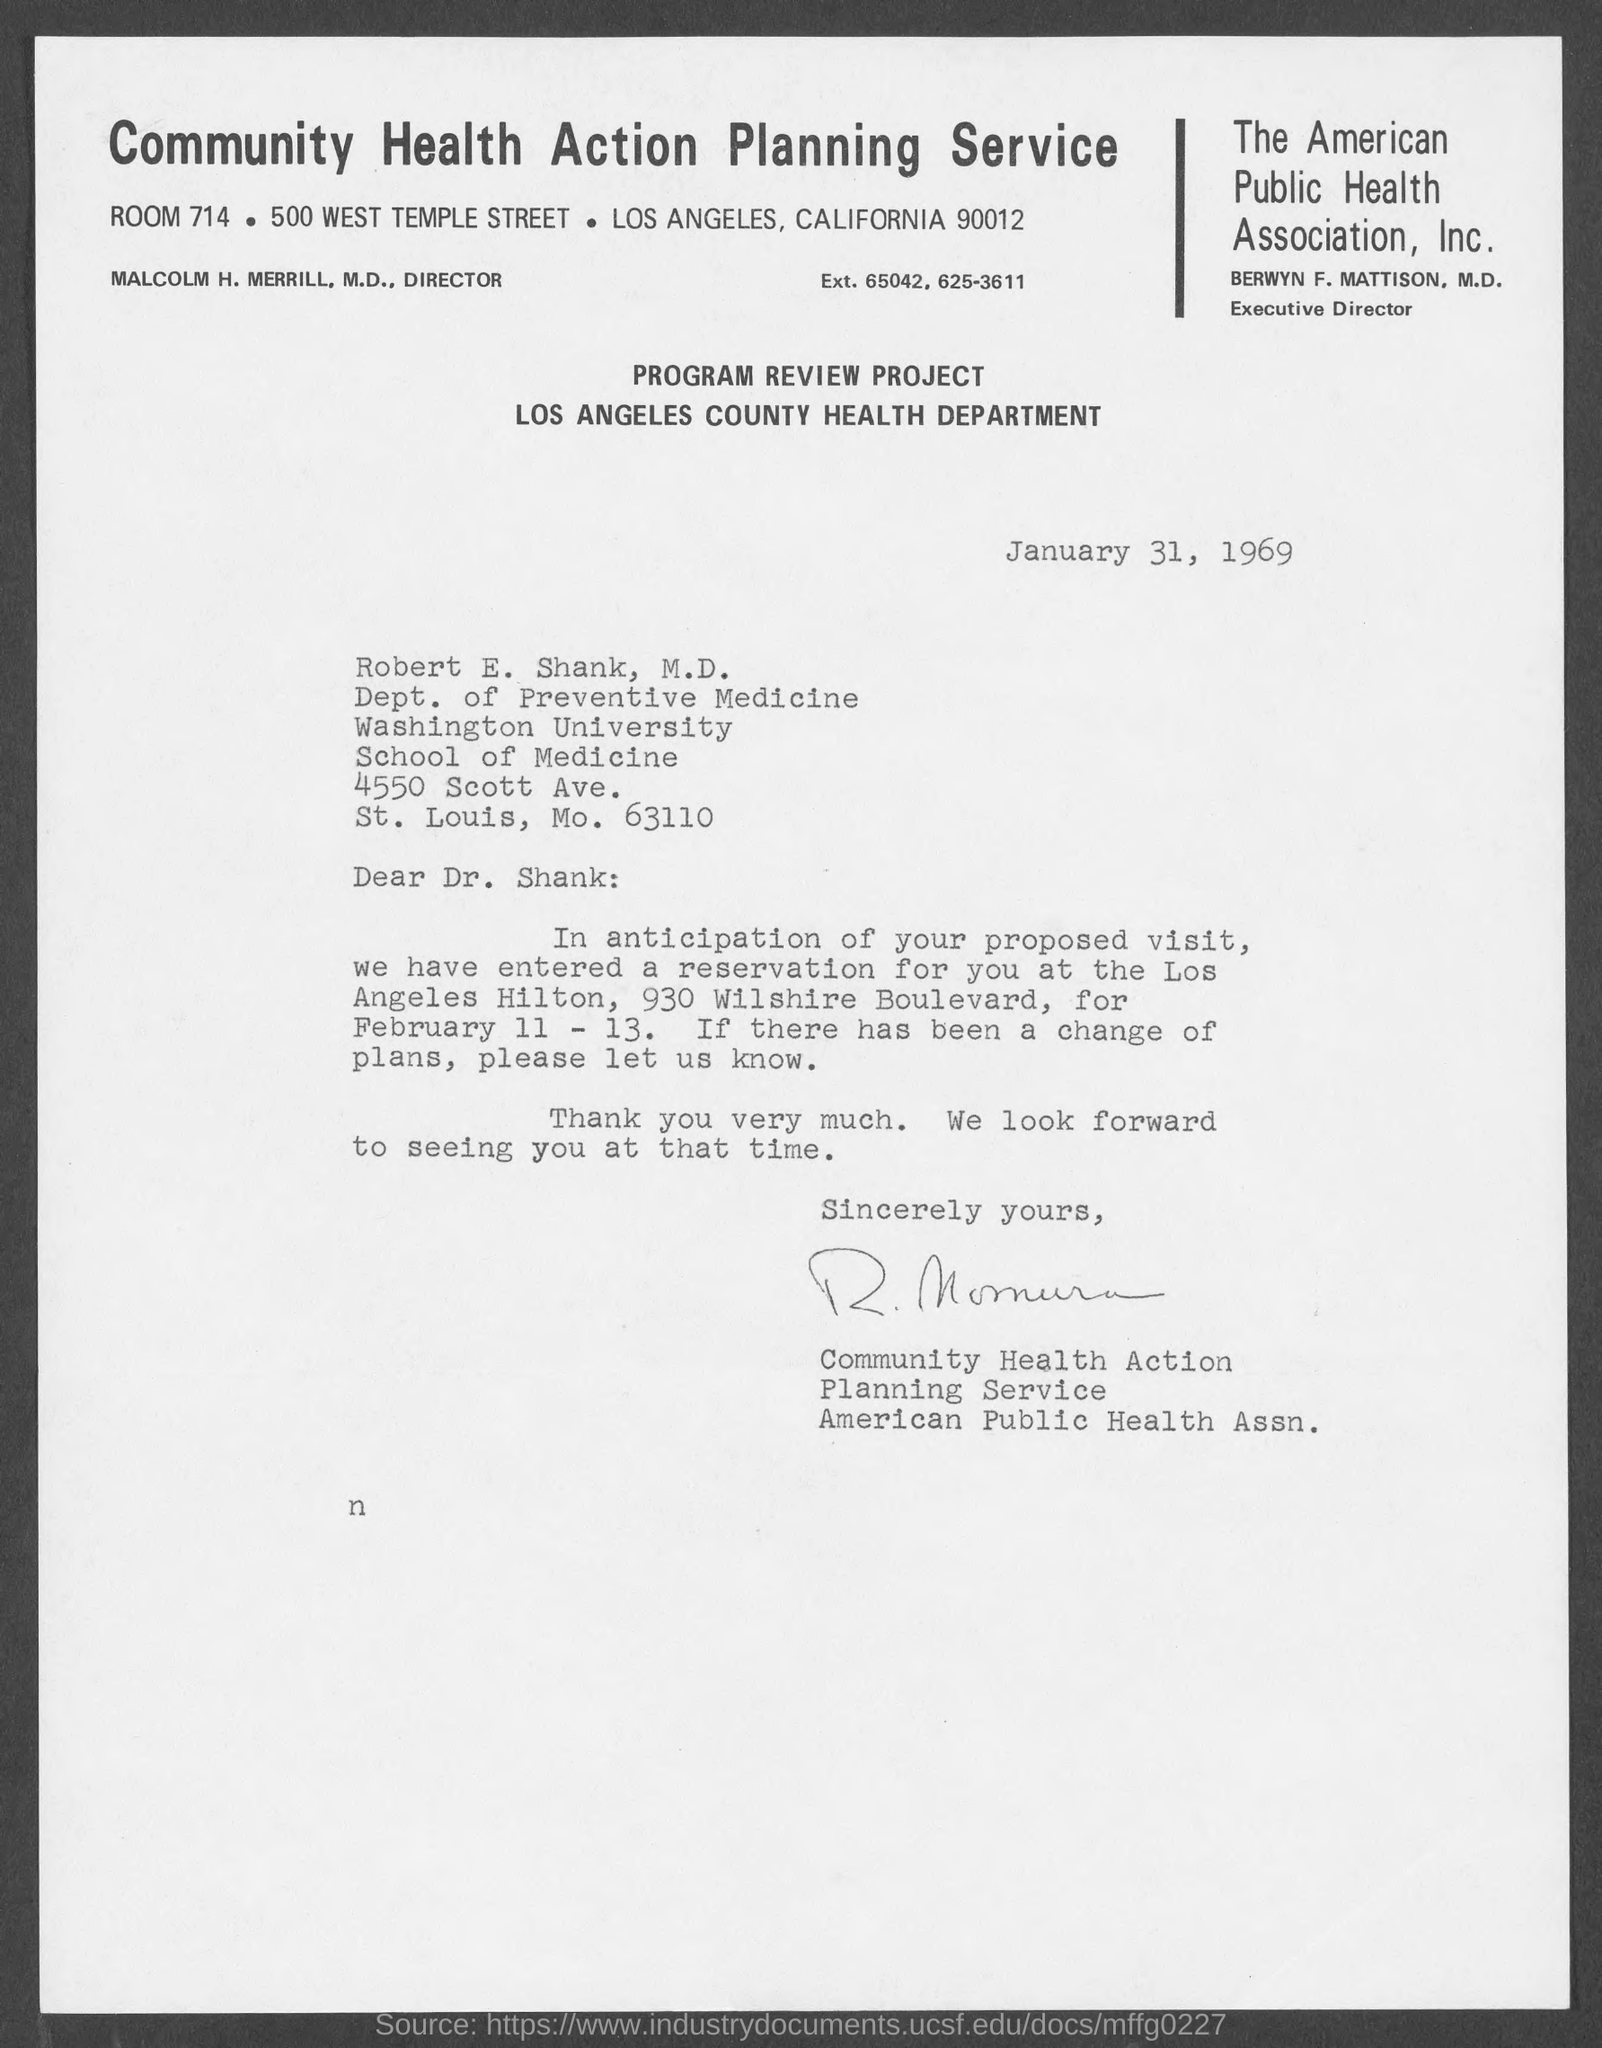Highlight a few significant elements in this photo. The name of the Executive Director is Berwyn F. Mattison, M.D. This letter is written on January 31, 1969. I, [Name], do hereby declare that the name of the public health association is The American Public Health Association, Inc. The community health action planning service is located in room 714. 